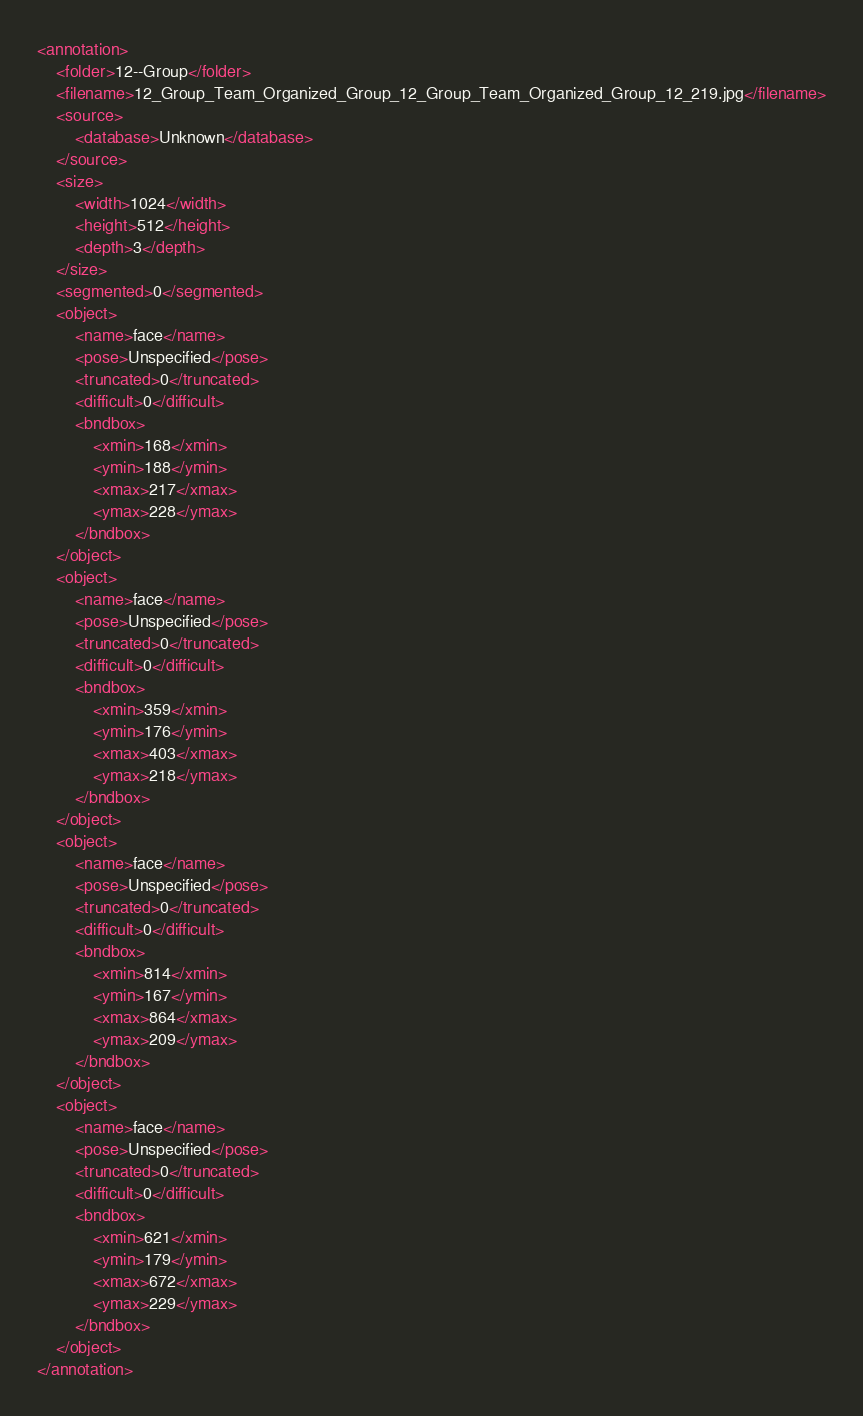<code> <loc_0><loc_0><loc_500><loc_500><_XML_><annotation>
    <folder>12--Group</folder>
    <filename>12_Group_Team_Organized_Group_12_Group_Team_Organized_Group_12_219.jpg</filename>
    <source>
        <database>Unknown</database>
    </source>
    <size>
        <width>1024</width>
        <height>512</height>
        <depth>3</depth>
    </size>
    <segmented>0</segmented>
    <object>
        <name>face</name>
        <pose>Unspecified</pose>
        <truncated>0</truncated>
        <difficult>0</difficult>
        <bndbox>
            <xmin>168</xmin>
            <ymin>188</ymin>
            <xmax>217</xmax>
            <ymax>228</ymax>
        </bndbox>
    </object>
    <object>
        <name>face</name>
        <pose>Unspecified</pose>
        <truncated>0</truncated>
        <difficult>0</difficult>
        <bndbox>
            <xmin>359</xmin>
            <ymin>176</ymin>
            <xmax>403</xmax>
            <ymax>218</ymax>
        </bndbox>
    </object>
    <object>
        <name>face</name>
        <pose>Unspecified</pose>
        <truncated>0</truncated>
        <difficult>0</difficult>
        <bndbox>
            <xmin>814</xmin>
            <ymin>167</ymin>
            <xmax>864</xmax>
            <ymax>209</ymax>
        </bndbox>
    </object>
    <object>
        <name>face</name>
        <pose>Unspecified</pose>
        <truncated>0</truncated>
        <difficult>0</difficult>
        <bndbox>
            <xmin>621</xmin>
            <ymin>179</ymin>
            <xmax>672</xmax>
            <ymax>229</ymax>
        </bndbox>
    </object>
</annotation>
</code> 